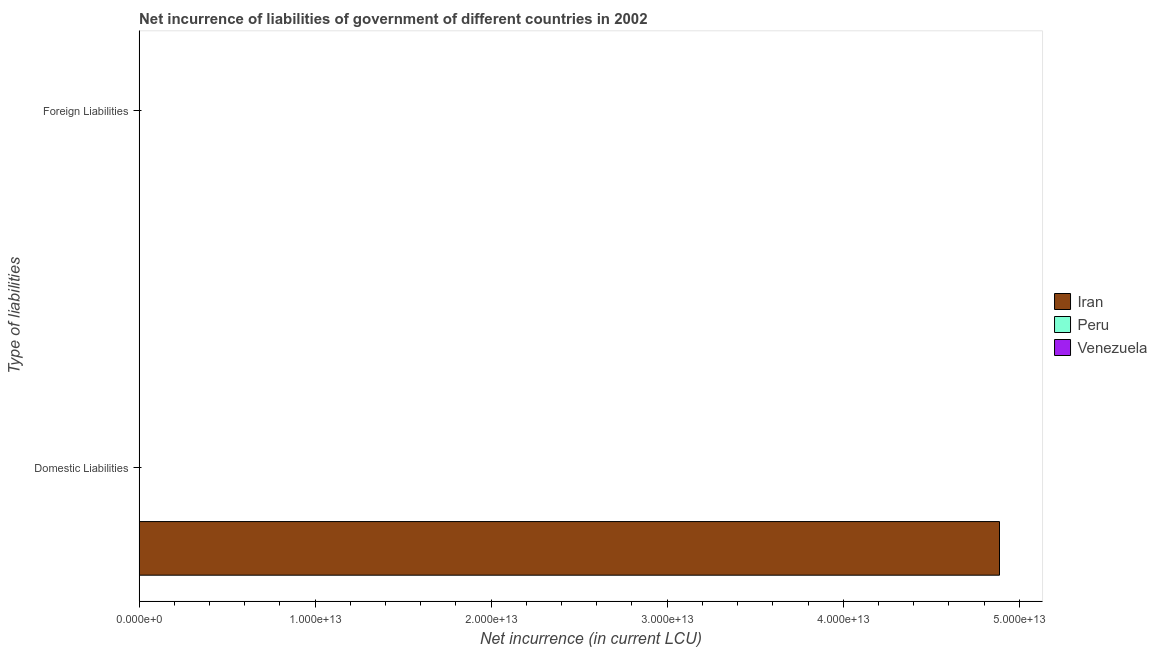How many different coloured bars are there?
Your answer should be compact. 3. How many bars are there on the 1st tick from the bottom?
Provide a short and direct response. 3. What is the label of the 2nd group of bars from the top?
Provide a short and direct response. Domestic Liabilities. What is the net incurrence of foreign liabilities in Venezuela?
Offer a very short reply. 0. Across all countries, what is the maximum net incurrence of domestic liabilities?
Offer a terse response. 4.89e+13. Across all countries, what is the minimum net incurrence of domestic liabilities?
Offer a terse response. 7.33e+08. What is the total net incurrence of domestic liabilities in the graph?
Your response must be concise. 4.89e+13. What is the difference between the net incurrence of domestic liabilities in Venezuela and that in Peru?
Provide a succinct answer. 2.68e+09. What is the difference between the net incurrence of foreign liabilities in Iran and the net incurrence of domestic liabilities in Venezuela?
Your response must be concise. -3.41e+09. What is the average net incurrence of domestic liabilities per country?
Your response must be concise. 1.63e+13. What is the difference between the net incurrence of domestic liabilities and net incurrence of foreign liabilities in Peru?
Offer a terse response. -9.45e+09. In how many countries, is the net incurrence of domestic liabilities greater than 24000000000000 LCU?
Provide a short and direct response. 1. What is the ratio of the net incurrence of domestic liabilities in Venezuela to that in Peru?
Make the answer very short. 4.66. How many countries are there in the graph?
Ensure brevity in your answer.  3. What is the difference between two consecutive major ticks on the X-axis?
Offer a terse response. 1.00e+13. How many legend labels are there?
Ensure brevity in your answer.  3. How are the legend labels stacked?
Give a very brief answer. Vertical. What is the title of the graph?
Ensure brevity in your answer.  Net incurrence of liabilities of government of different countries in 2002. Does "Burkina Faso" appear as one of the legend labels in the graph?
Provide a short and direct response. No. What is the label or title of the X-axis?
Offer a terse response. Net incurrence (in current LCU). What is the label or title of the Y-axis?
Offer a very short reply. Type of liabilities. What is the Net incurrence (in current LCU) in Iran in Domestic Liabilities?
Your response must be concise. 4.89e+13. What is the Net incurrence (in current LCU) in Peru in Domestic Liabilities?
Provide a short and direct response. 7.33e+08. What is the Net incurrence (in current LCU) of Venezuela in Domestic Liabilities?
Your response must be concise. 3.41e+09. What is the Net incurrence (in current LCU) of Peru in Foreign Liabilities?
Give a very brief answer. 1.02e+1. What is the Net incurrence (in current LCU) in Venezuela in Foreign Liabilities?
Ensure brevity in your answer.  0. Across all Type of liabilities, what is the maximum Net incurrence (in current LCU) in Iran?
Give a very brief answer. 4.89e+13. Across all Type of liabilities, what is the maximum Net incurrence (in current LCU) in Peru?
Ensure brevity in your answer.  1.02e+1. Across all Type of liabilities, what is the maximum Net incurrence (in current LCU) of Venezuela?
Make the answer very short. 3.41e+09. Across all Type of liabilities, what is the minimum Net incurrence (in current LCU) of Peru?
Your answer should be very brief. 7.33e+08. What is the total Net incurrence (in current LCU) of Iran in the graph?
Offer a terse response. 4.89e+13. What is the total Net incurrence (in current LCU) in Peru in the graph?
Provide a succinct answer. 1.09e+1. What is the total Net incurrence (in current LCU) in Venezuela in the graph?
Your answer should be very brief. 3.41e+09. What is the difference between the Net incurrence (in current LCU) of Peru in Domestic Liabilities and that in Foreign Liabilities?
Provide a succinct answer. -9.45e+09. What is the difference between the Net incurrence (in current LCU) in Iran in Domestic Liabilities and the Net incurrence (in current LCU) in Peru in Foreign Liabilities?
Offer a very short reply. 4.89e+13. What is the average Net incurrence (in current LCU) of Iran per Type of liabilities?
Offer a very short reply. 2.44e+13. What is the average Net incurrence (in current LCU) in Peru per Type of liabilities?
Give a very brief answer. 5.46e+09. What is the average Net incurrence (in current LCU) in Venezuela per Type of liabilities?
Offer a very short reply. 1.71e+09. What is the difference between the Net incurrence (in current LCU) in Iran and Net incurrence (in current LCU) in Peru in Domestic Liabilities?
Ensure brevity in your answer.  4.89e+13. What is the difference between the Net incurrence (in current LCU) in Iran and Net incurrence (in current LCU) in Venezuela in Domestic Liabilities?
Give a very brief answer. 4.89e+13. What is the difference between the Net incurrence (in current LCU) in Peru and Net incurrence (in current LCU) in Venezuela in Domestic Liabilities?
Offer a terse response. -2.68e+09. What is the ratio of the Net incurrence (in current LCU) of Peru in Domestic Liabilities to that in Foreign Liabilities?
Provide a short and direct response. 0.07. What is the difference between the highest and the second highest Net incurrence (in current LCU) of Peru?
Offer a very short reply. 9.45e+09. What is the difference between the highest and the lowest Net incurrence (in current LCU) in Iran?
Provide a succinct answer. 4.89e+13. What is the difference between the highest and the lowest Net incurrence (in current LCU) of Peru?
Give a very brief answer. 9.45e+09. What is the difference between the highest and the lowest Net incurrence (in current LCU) of Venezuela?
Your response must be concise. 3.41e+09. 